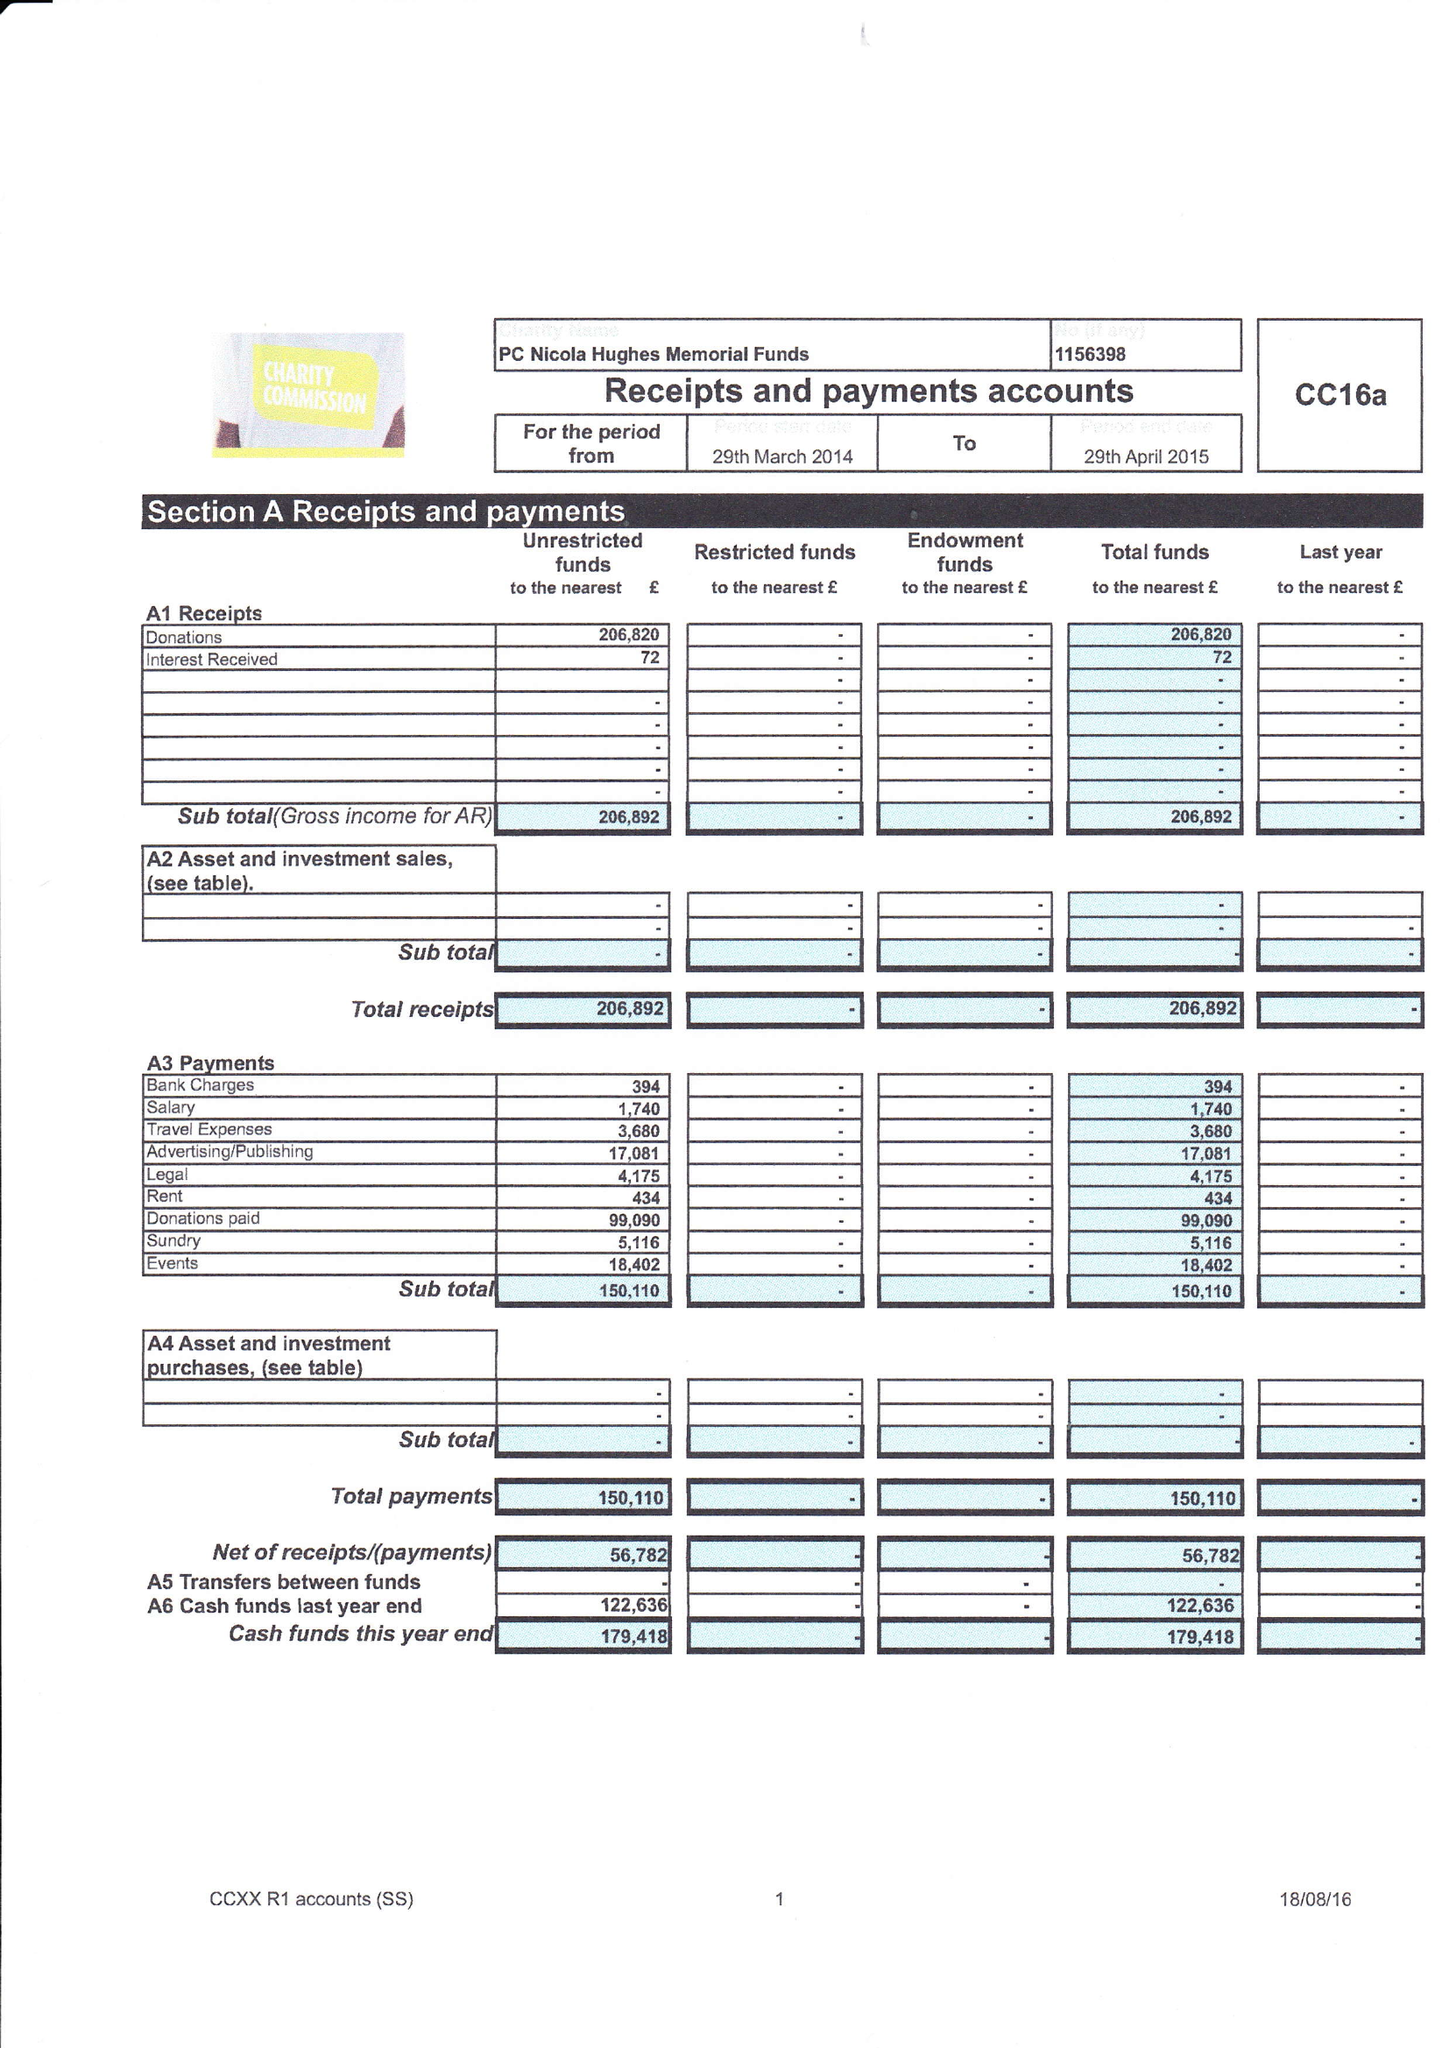What is the value for the address__postcode?
Answer the question using a single word or phrase. OL3 5DE 